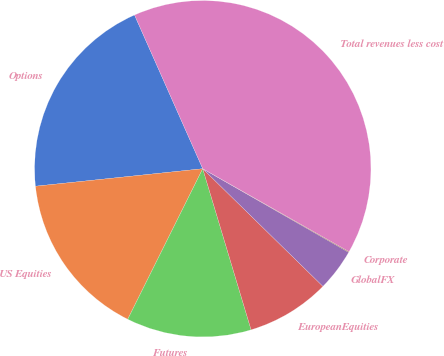<chart> <loc_0><loc_0><loc_500><loc_500><pie_chart><fcel>Options<fcel>US Equities<fcel>Futures<fcel>EuropeanEquities<fcel>GlobalFX<fcel>Corporate<fcel>Total revenues less cost<nl><fcel>20.01%<fcel>15.98%<fcel>12.0%<fcel>8.03%<fcel>4.05%<fcel>0.07%<fcel>39.86%<nl></chart> 